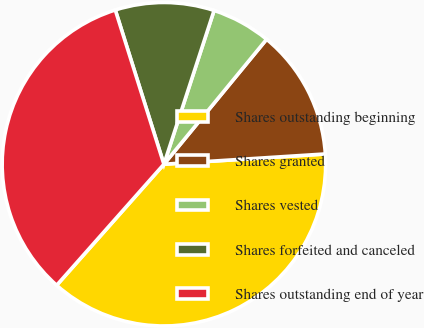<chart> <loc_0><loc_0><loc_500><loc_500><pie_chart><fcel>Shares outstanding beginning<fcel>Shares granted<fcel>Shares vested<fcel>Shares forfeited and canceled<fcel>Shares outstanding end of year<nl><fcel>37.55%<fcel>13.04%<fcel>5.93%<fcel>9.88%<fcel>33.6%<nl></chart> 